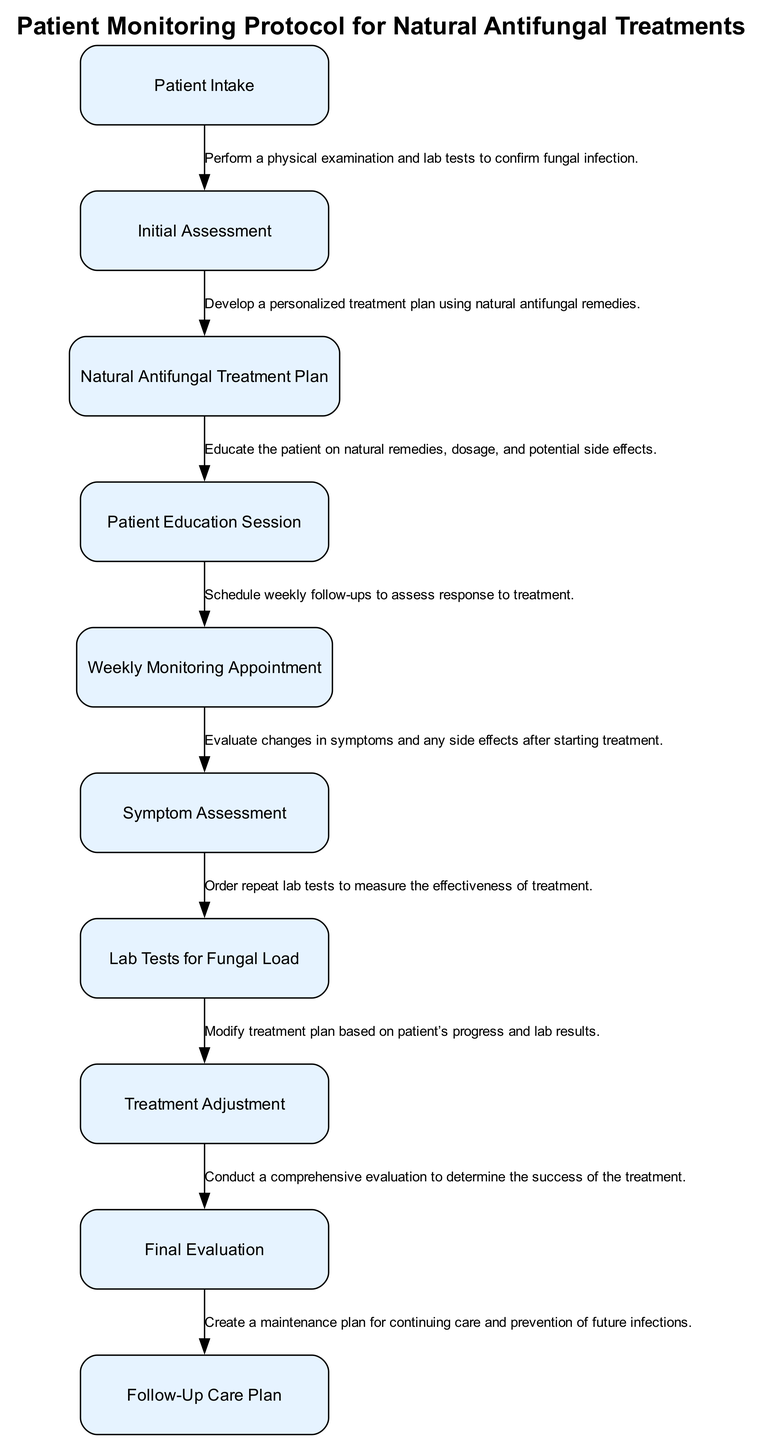What is the first step in the patient monitoring protocol? The first step in the protocol is "Patient Intake," where the patient's history and symptoms related to fungal infections are collected. This is indicated as the first element in the diagram.
Answer: Patient Intake How many nodes are present in the diagram? The diagram contains ten nodes, each representing a step in the patient monitoring protocol for assessing natural antifungal treatments.
Answer: Ten What is the relationship between "Initial Assessment" and "Natural Antifungal Treatment Plan"? "Initial Assessment" leads directly to "Natural Antifungal Treatment Plan," as indicated by the flow of the diagram, showing that after the assessment, a treatment plan is developed.
Answer: Sequential What does the "Weekly Monitoring Appointment" evaluate? The "Weekly Monitoring Appointment" evaluates the response to the natural antifungal treatment, which is reflected in the description of this node in the diagram.
Answer: Response to treatment Which step comes after "Symptom Assessment"? The step that follows "Symptom Assessment" is "Lab Tests for Fungal Load," as the diagram indicates a clear sequence leading from one to the next.
Answer: Lab Tests for Fungal Load What is the final step in the protocol? The final step in the protocol is "Follow-Up Care Plan," designed to create a maintenance plan for continued care and prevention of future infections.
Answer: Follow-Up Care Plan How does "Treatment Adjustment" relate to "Patient Education Session"? "Treatment Adjustment" is influenced by the results of the "Symptom Assessment" and "Lab Tests for Fungal Load," while "Patient Education Session" comes earlier in the sequence, serving to inform the patient about the treatment. Thus, they are indirectly related through the treatment process.
Answer: Indirectly related What is the purpose of the "Final Evaluation"? The "Final Evaluation" aims to conduct a comprehensive evaluation to determine the success of the treatment, as described in the diagram.
Answer: Evaluate success In terms of sequences, which node follows "Patient Education Session"? The node that follows "Patient Education Session" in the sequence is "Weekly Monitoring Appointment," indicating the subsequent steps after patient education.
Answer: Weekly Monitoring Appointment 